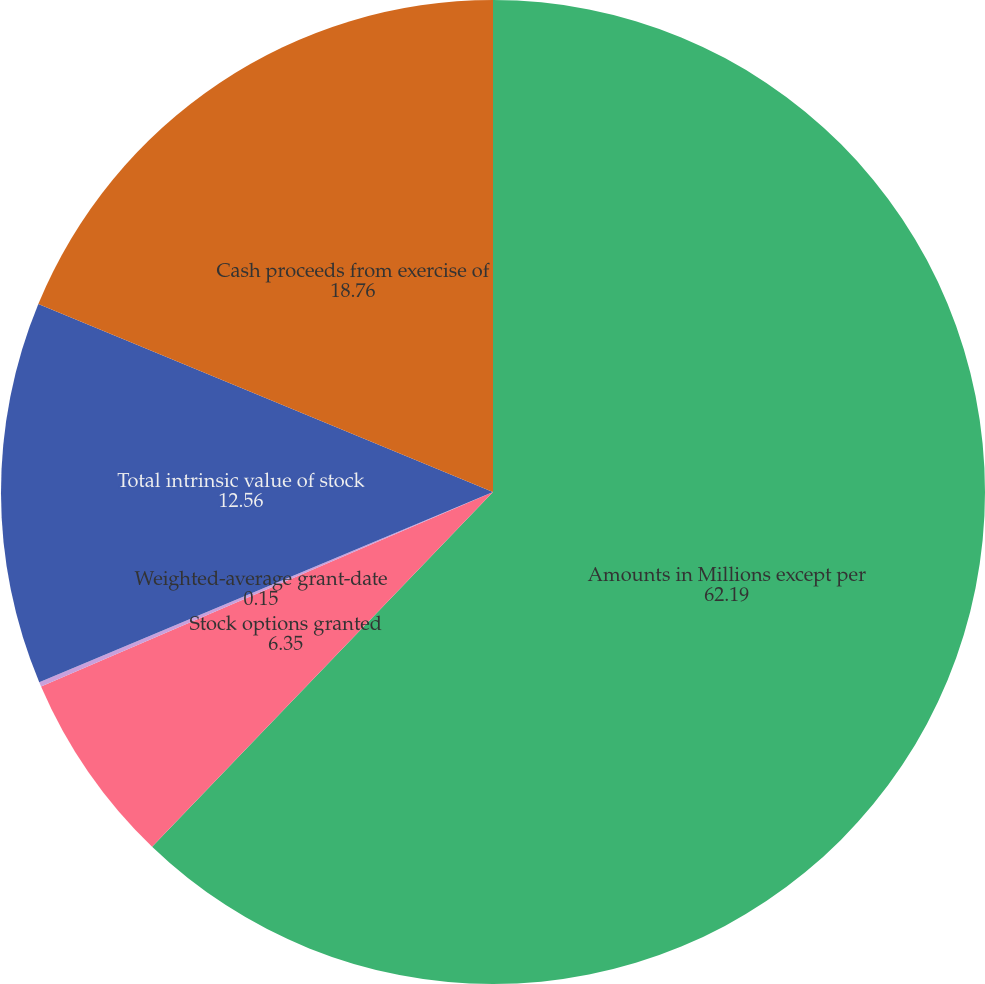Convert chart. <chart><loc_0><loc_0><loc_500><loc_500><pie_chart><fcel>Amounts in Millions except per<fcel>Stock options granted<fcel>Weighted-average grant-date<fcel>Total intrinsic value of stock<fcel>Cash proceeds from exercise of<nl><fcel>62.19%<fcel>6.35%<fcel>0.15%<fcel>12.56%<fcel>18.76%<nl></chart> 